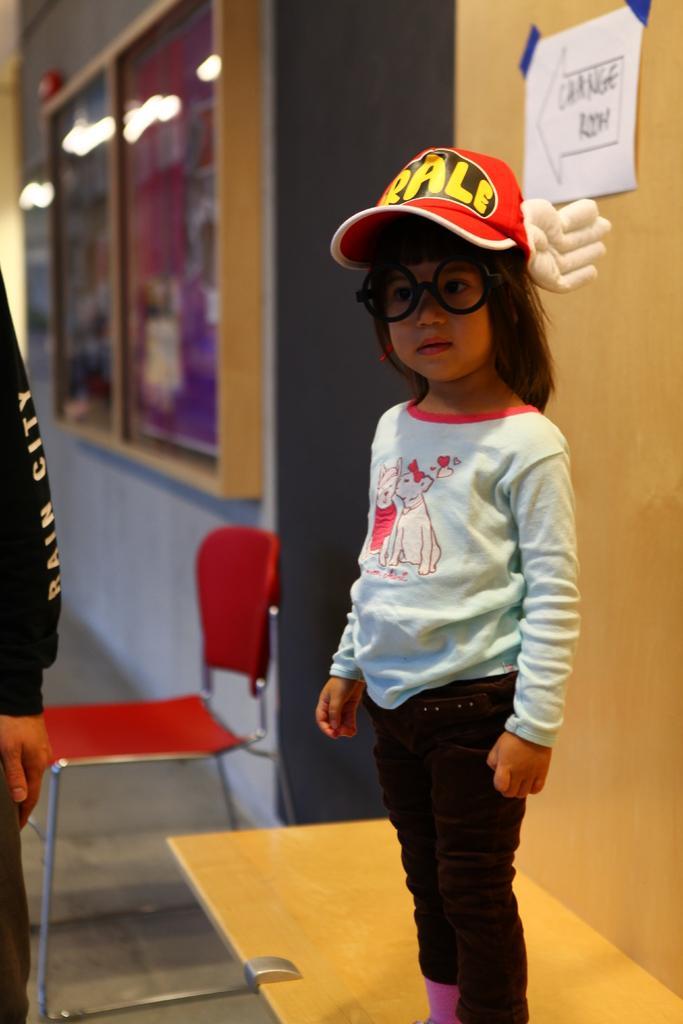Could you give a brief overview of what you see in this image? In this picture there is a girl with red cap is standing. On the left side of the image there is a person. At the back there is a chair and there is a board on the wall and there are posters on the board and there are reflections of lights on the mirror and there is a paper on the wall and there is text on the paper. At the bottom there is a floor. 